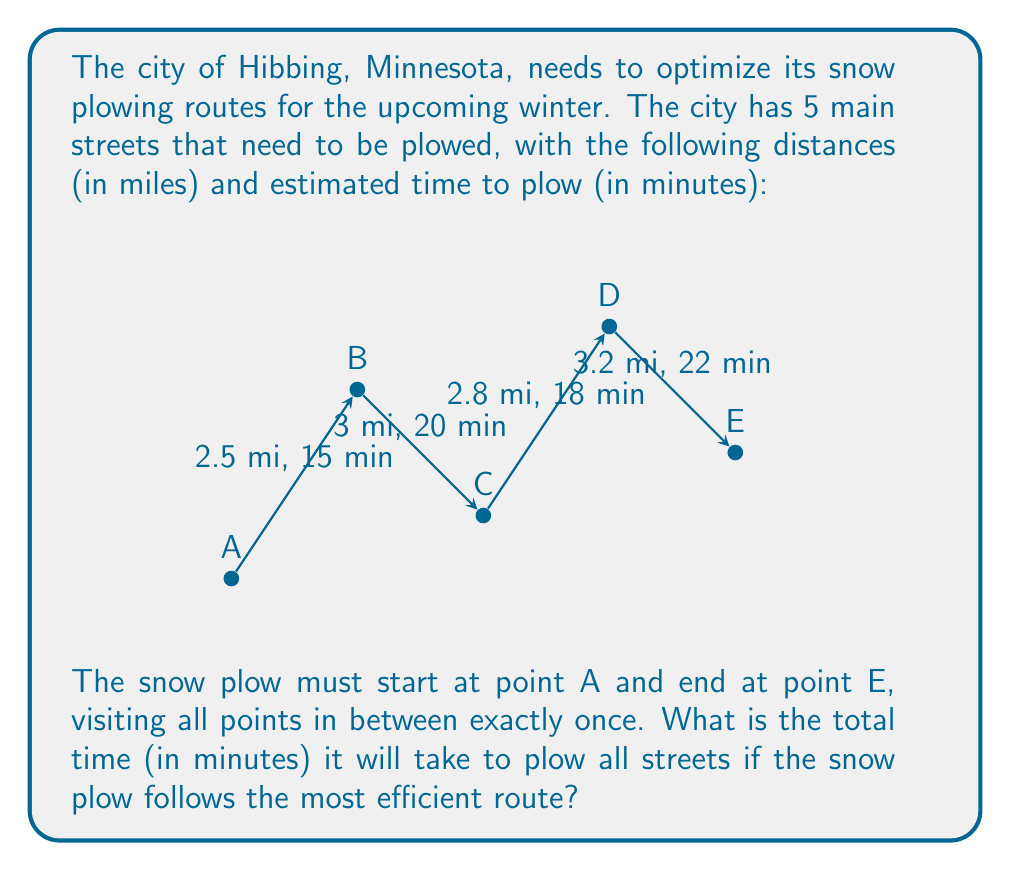Give your solution to this math problem. To solve this problem, we need to follow these steps:

1. Recognize that this is a simple path problem where we need to visit all points in a specific order.

2. The path is already determined: A → B → C → D → E

3. Calculate the total time by summing up the time for each segment:

   A to B: 15 minutes
   B to C: 20 minutes
   C to D: 18 minutes
   D to E: 22 minutes

4. Sum up all the times:

   $$\text{Total Time} = 15 + 20 + 18 + 22 = 75 \text{ minutes}$$

Therefore, it will take 75 minutes to plow all streets following the most efficient (and only possible) route from A to E.
Answer: 75 minutes 